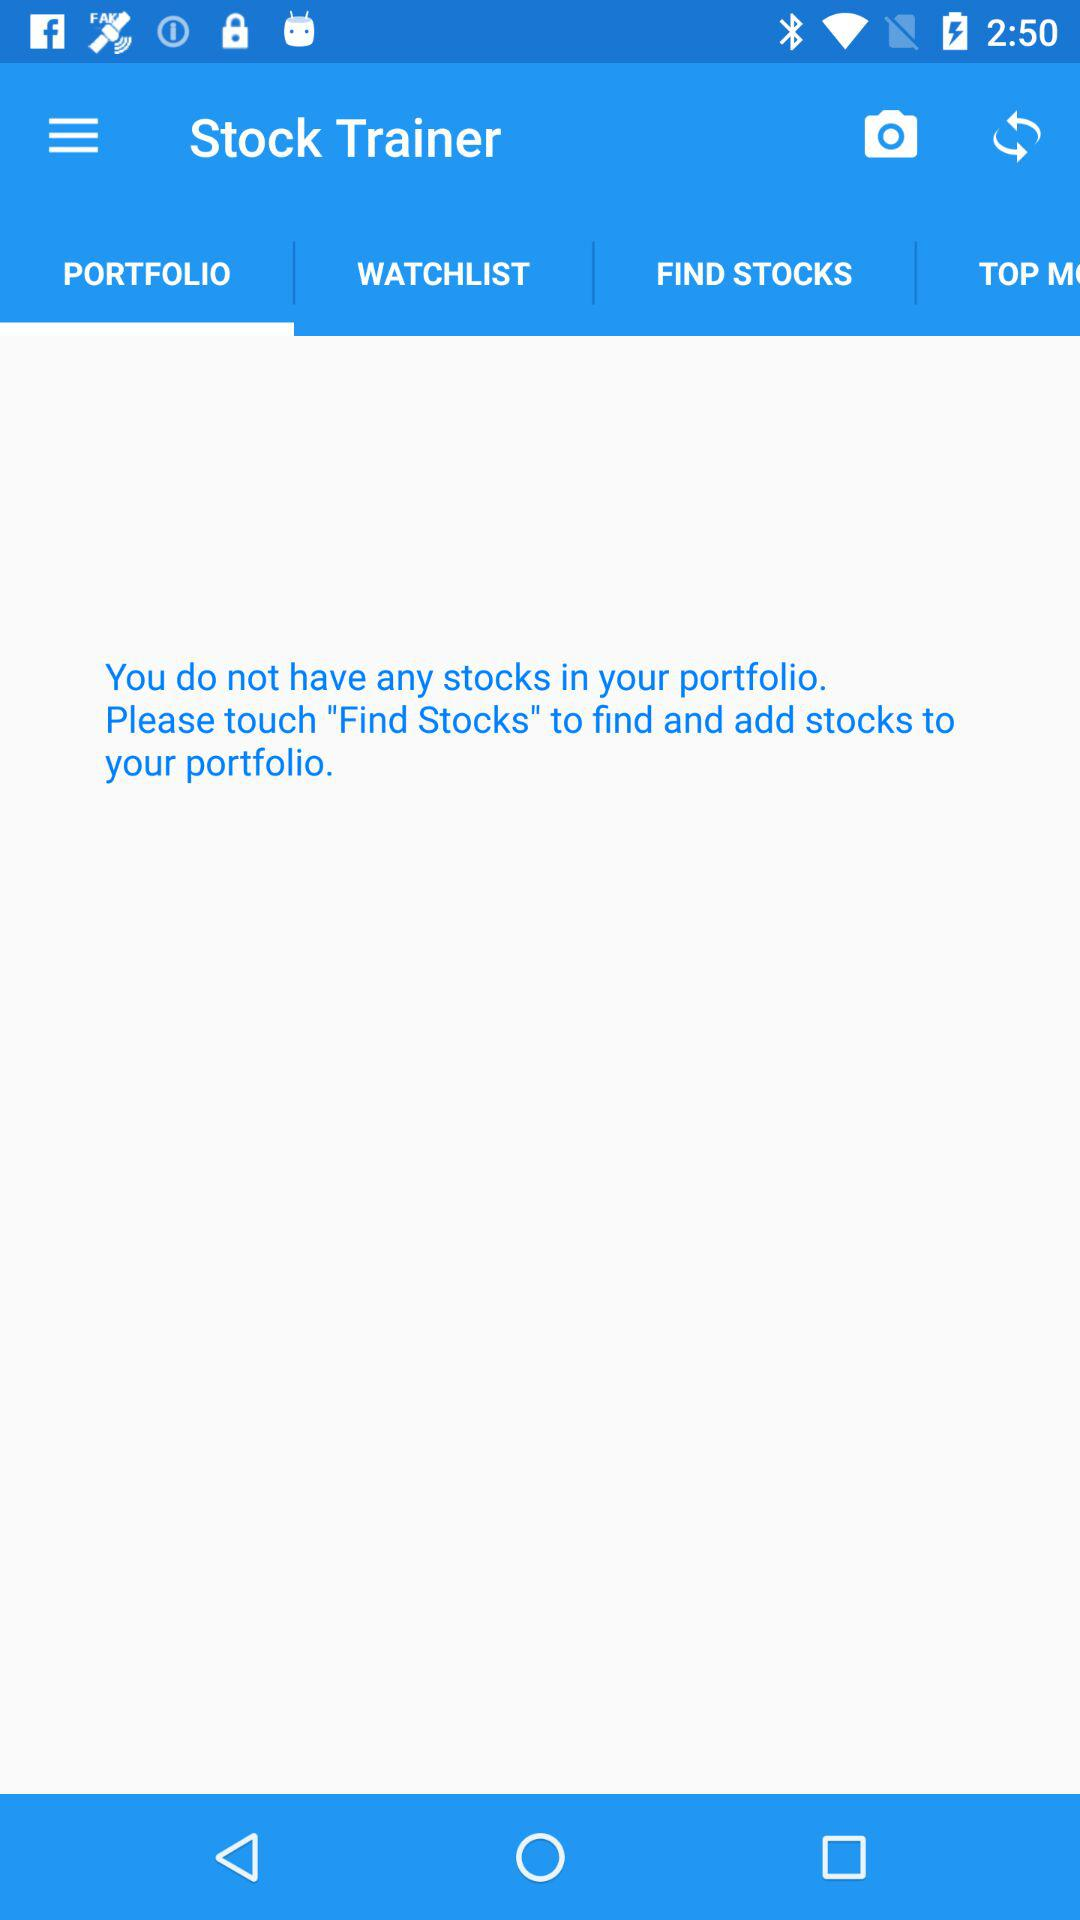What is the name of the application? The name of the application is "Stock Trainer". 